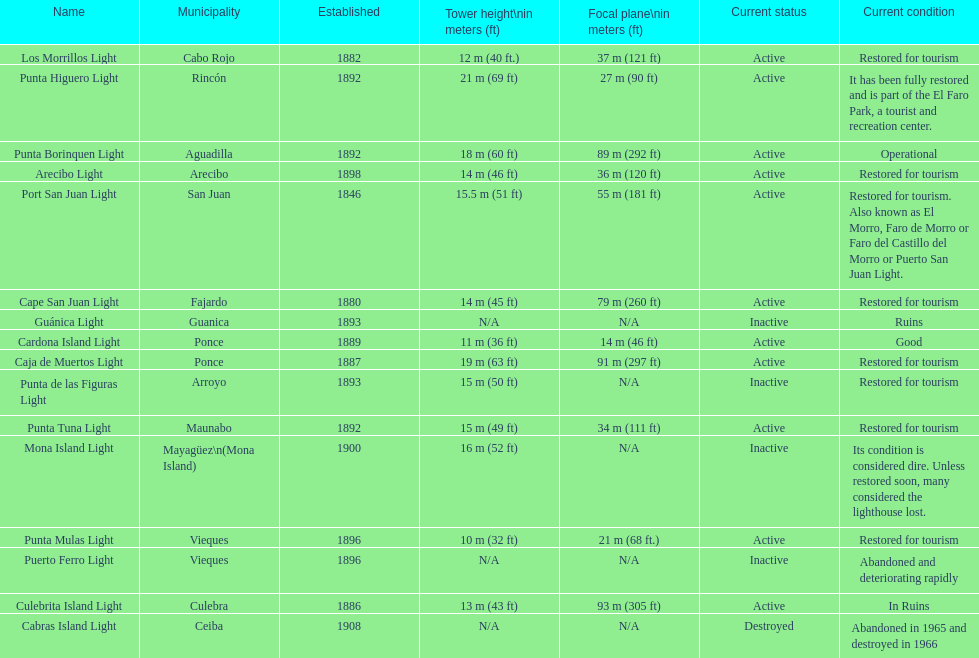What is the number of establishments that have been restored for tourism purposes? 9. 